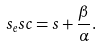<formula> <loc_0><loc_0><loc_500><loc_500>s _ { e } s c = s + \frac { \beta } { \alpha } .</formula> 